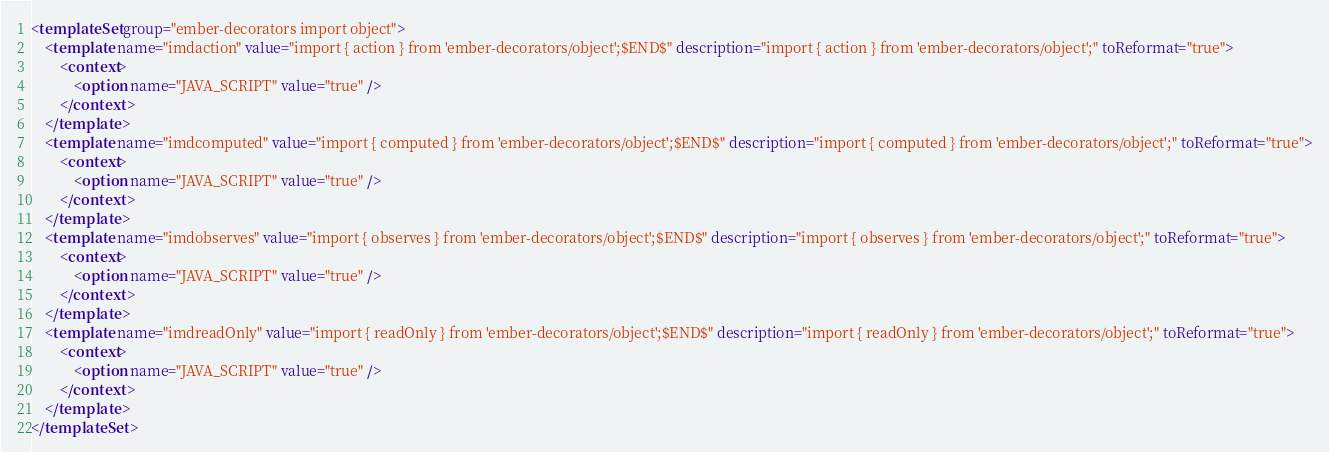Convert code to text. <code><loc_0><loc_0><loc_500><loc_500><_XML_><templateSet group="ember-decorators import object">
	<template name="imdaction" value="import { action } from 'ember-decorators/object';$END$" description="import { action } from 'ember-decorators/object';" toReformat="true">
        <context>
            <option name="JAVA_SCRIPT" value="true" />
        </context>
    </template>
    <template name="imdcomputed" value="import { computed } from 'ember-decorators/object';$END$" description="import { computed } from 'ember-decorators/object';" toReformat="true">
        <context>
            <option name="JAVA_SCRIPT" value="true" />
        </context>
    </template>
    <template name="imdobserves" value="import { observes } from 'ember-decorators/object';$END$" description="import { observes } from 'ember-decorators/object';" toReformat="true">
        <context>
            <option name="JAVA_SCRIPT" value="true" />
        </context>
    </template>
    <template name="imdreadOnly" value="import { readOnly } from 'ember-decorators/object';$END$" description="import { readOnly } from 'ember-decorators/object';" toReformat="true">
        <context>
            <option name="JAVA_SCRIPT" value="true" />
        </context>
    </template>
</templateSet></code> 